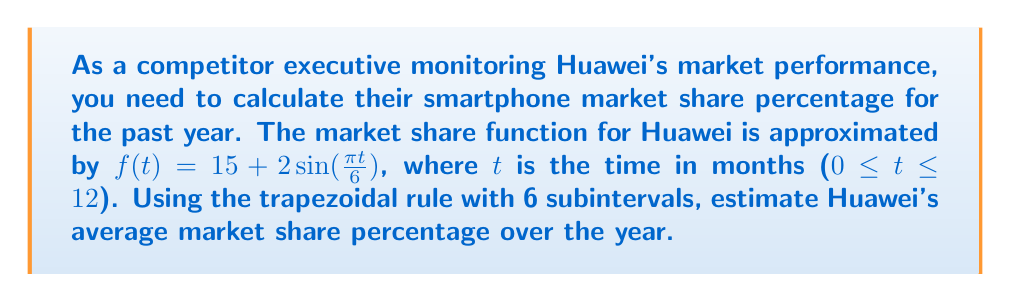Show me your answer to this math problem. To solve this problem, we'll use the trapezoidal rule for numerical integration:

1) The trapezoidal rule formula for n subintervals is:

   $$\int_{a}^{b} f(x) dx \approx \frac{b-a}{2n} [f(a) + 2f(x_1) + 2f(x_2) + ... + 2f(x_{n-1}) + f(b)]$$

2) Here, a = 0, b = 12, n = 6, and $\Delta t = \frac{b-a}{n} = \frac{12-0}{6} = 2$

3) We need to calculate f(t) for t = 0, 2, 4, 6, 8, 10, 12:

   $f(0) = 15 + 2\sin(0) = 15$
   $f(2) = 15 + 2\sin(\frac{\pi}{3}) \approx 16.732$
   $f(4) = 15 + 2\sin(\frac{2\pi}{3}) \approx 16.732$
   $f(6) = 15 + 2\sin(\pi) = 15$
   $f(8) = 15 + 2\sin(\frac{4\pi}{3}) \approx 13.268$
   $f(10) = 15 + 2\sin(\frac{5\pi}{3}) \approx 13.268$
   $f(12) = 15 + 2\sin(2\pi) = 15$

4) Applying the trapezoidal rule:

   $$\frac{12-0}{2(6)} [15 + 2(16.732 + 16.732 + 15 + 13.268 + 13.268) + 15]$$
   $$= 1 [15 + 2(75) + 15]$$
   $$= 1 [15 + 150 + 15]$$
   $$= 180$$

5) To get the average, divide by the interval (12 months):

   $\frac{180}{12} = 15$

Therefore, Huawei's estimated average market share percentage over the year is 15%.
Answer: 15% 